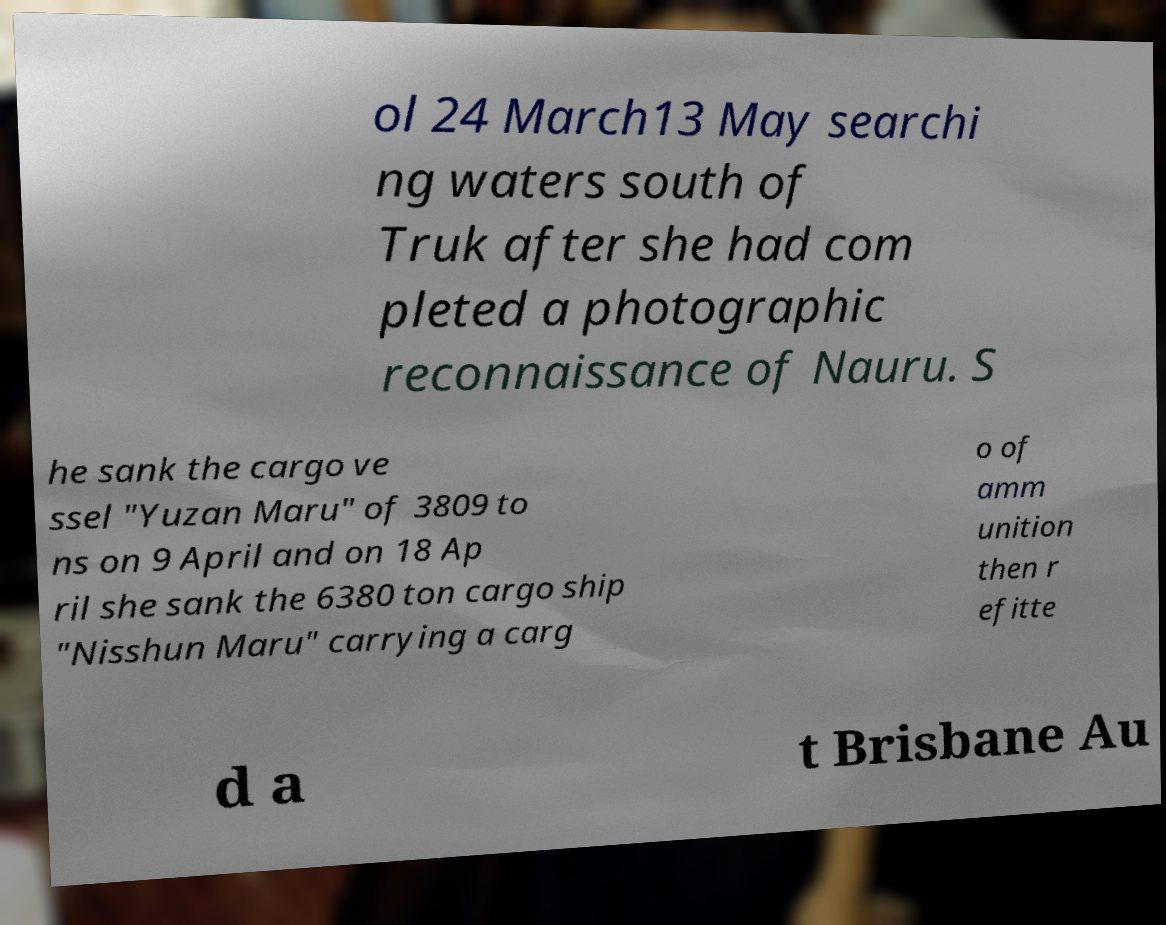Can you accurately transcribe the text from the provided image for me? ol 24 March13 May searchi ng waters south of Truk after she had com pleted a photographic reconnaissance of Nauru. S he sank the cargo ve ssel "Yuzan Maru" of 3809 to ns on 9 April and on 18 Ap ril she sank the 6380 ton cargo ship "Nisshun Maru" carrying a carg o of amm unition then r efitte d a t Brisbane Au 